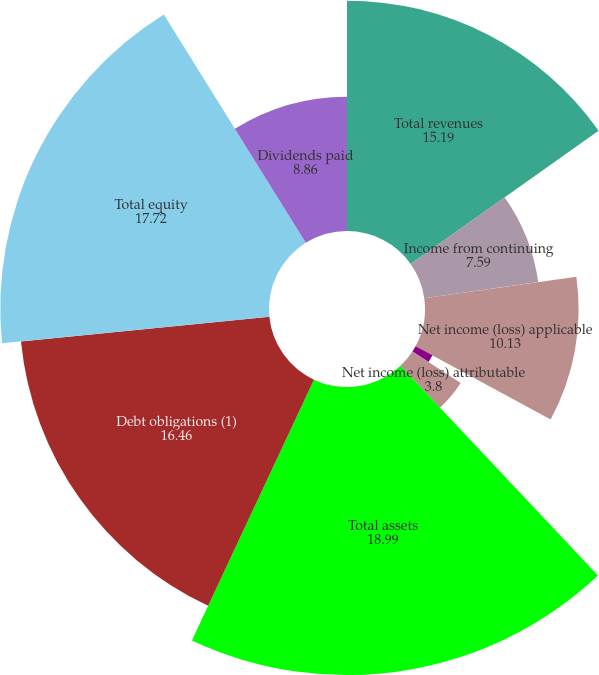Convert chart to OTSL. <chart><loc_0><loc_0><loc_500><loc_500><pie_chart><fcel>Total revenues<fcel>Income from continuing<fcel>Net income (loss) applicable<fcel>Continuing operations<fcel>Discontinued operations<fcel>Net income (loss) attributable<fcel>Total assets<fcel>Debt obligations (1)<fcel>Total equity<fcel>Dividends paid<nl><fcel>15.19%<fcel>7.59%<fcel>10.13%<fcel>0.0%<fcel>1.27%<fcel>3.8%<fcel>18.99%<fcel>16.46%<fcel>17.72%<fcel>8.86%<nl></chart> 